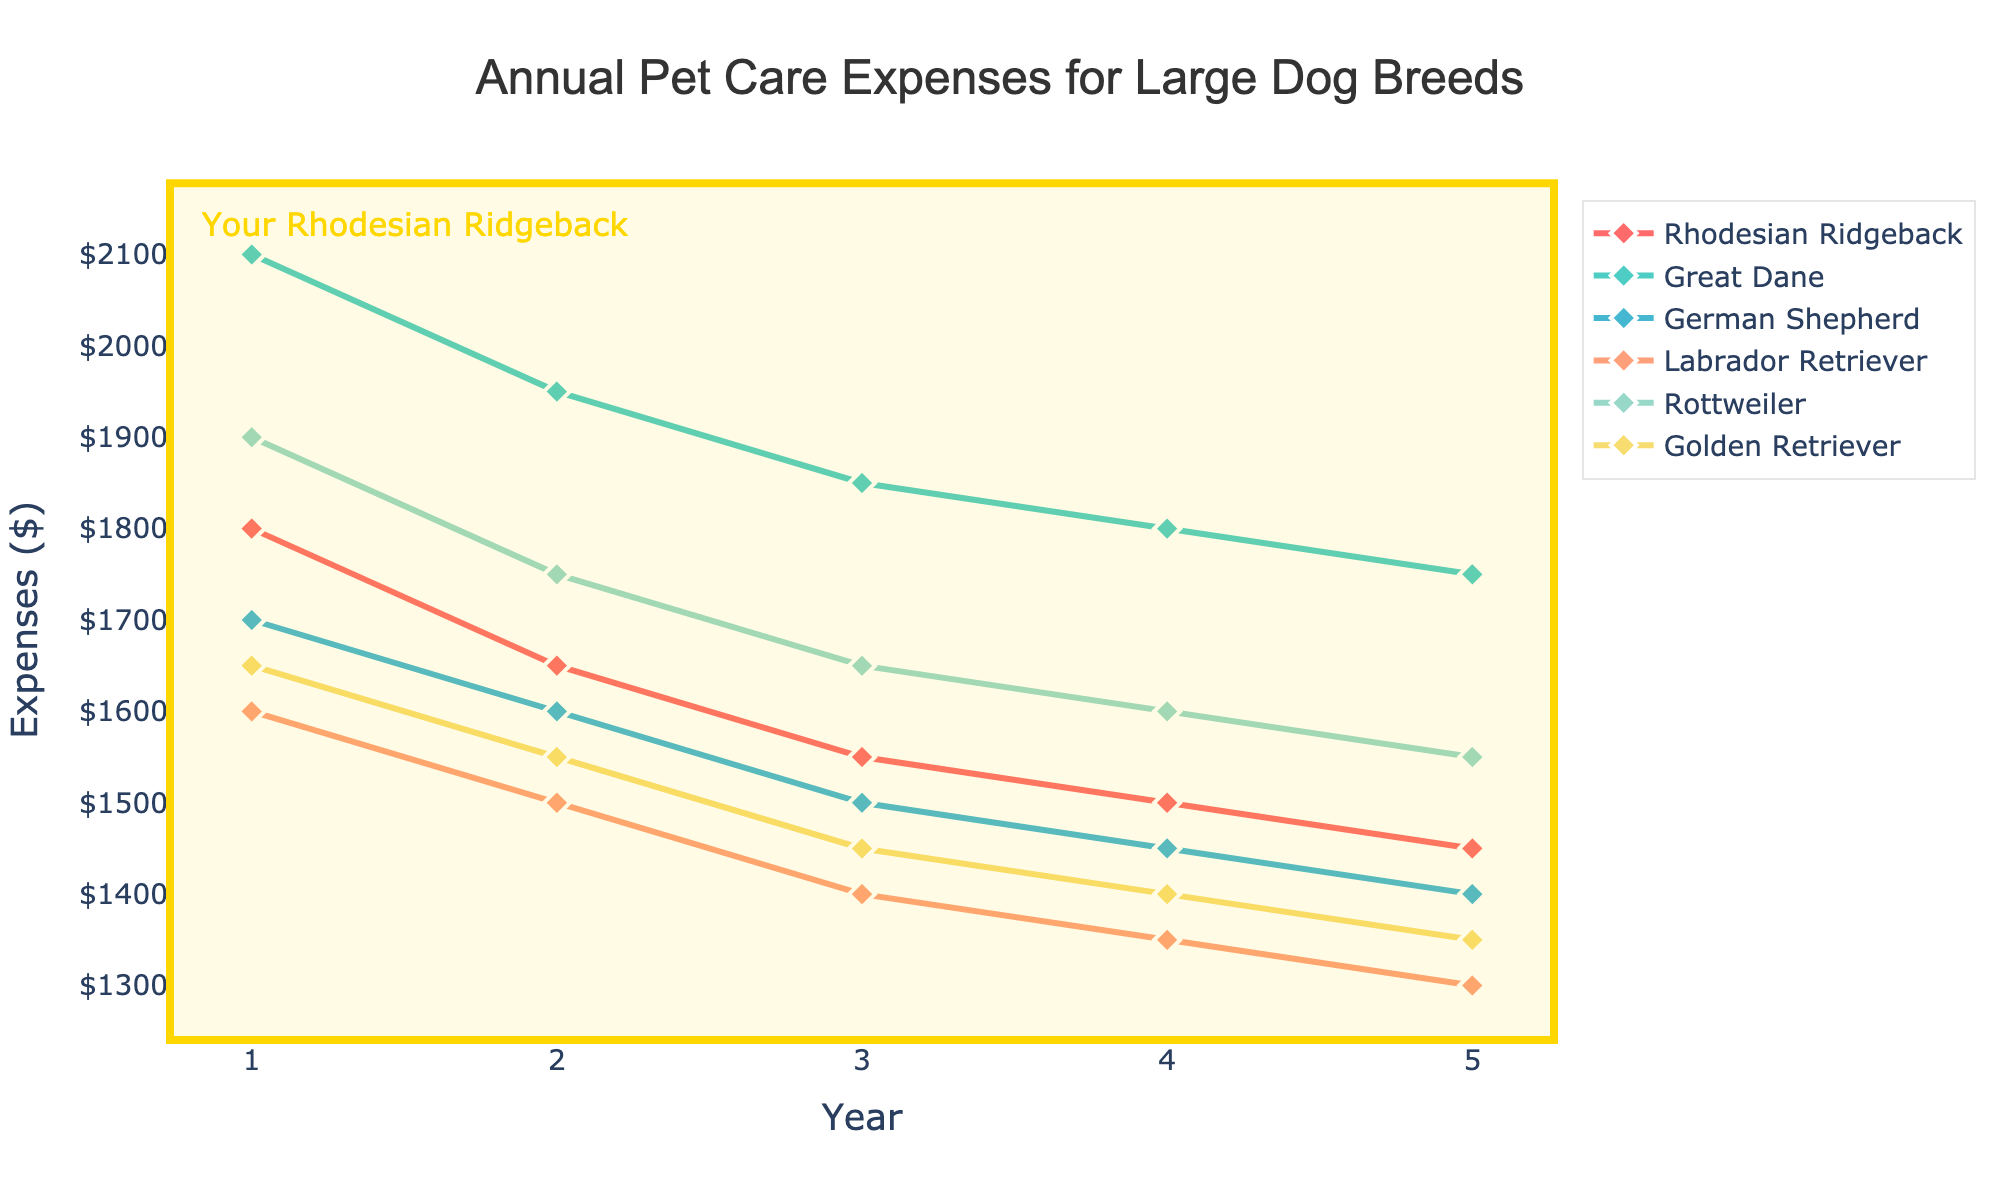What is the expense trend for Rhodesian Ridgeback over the 5 years? The plot shows the annual pet care expenses for Rhodesian Ridgeback from Year 1 to Year 5. Starting at $1800 in Year 1, the expenses steadily decrease each year to $1650 in Year 2, $1550 in Year 3, $1500 in Year 4, and reaching $1450 in Year 5.
Answer: Decreasing Which dog breed has the highest expense in Year 3? Observing the chart's lines and markers at Year 3, Great Dane has the highest expense at $1850 compared to the other breeds.
Answer: Great Dane How do the expenses of Rhodesian Ridgeback compare to Golden Retriever in Year 2? In Year 2, the expense for Rhodesian Ridgeback is $1650, while for Golden Retriever it is $1550. Comparing these two, Rhodesian Ridgeback has higher expenses.
Answer: Higher What is the average expense for Labrador Retriever over the 5 years? Sum the expenses for Labrador Retriever across the 5 years: $1600 (Year 1) + $1500 (Year 2) + $1400 (Year 3) + $1350 (Year 4) + $1300 (Year 5) = $7150, then divide by 5 to get the average.
Answer: $1430 Which breed has the steepest decline in expenses over the 5 years? Examine the slopes of all the lines. Great Dane shows the steepest decline, decreasing from $2100 to $1750, which is a difference of $350 over 5 years.
Answer: Great Dane What is the total expense for Rhodesian Ridgeback over the 5 years? Sum the expenses for Rhodesian Ridgeback across the 5 years: $1800 (Year 1) + $1650 (Year 2) + $1550 (Year 3) + $1500 (Year 4) + $1450 (Year 5).
Answer: $7950 Which breeds have an expense smaller than $1500 in Year 4? Looking at Year 4, the lower than $1500 expenses are for: German Shepherd ($1450), Labrador Retriever ($1350), and Golden Retriever ($1400).
Answer: German Shepherd, Labrador Retriever, Golden Retriever What is the difference in Year 5 expenses between Great Dane and Rhodesian Ridgeback? Subtract the Year 5 expense of Rhodesian Ridgeback ($1450) from the Year 5 expense of Great Dane ($1750).
Answer: $300 Which breed shows the smallest expense in Year 5? Observing the Year 5 expenses, Labrador Retriever has the smallest expense of $1300.
Answer: Labrador Retriever 